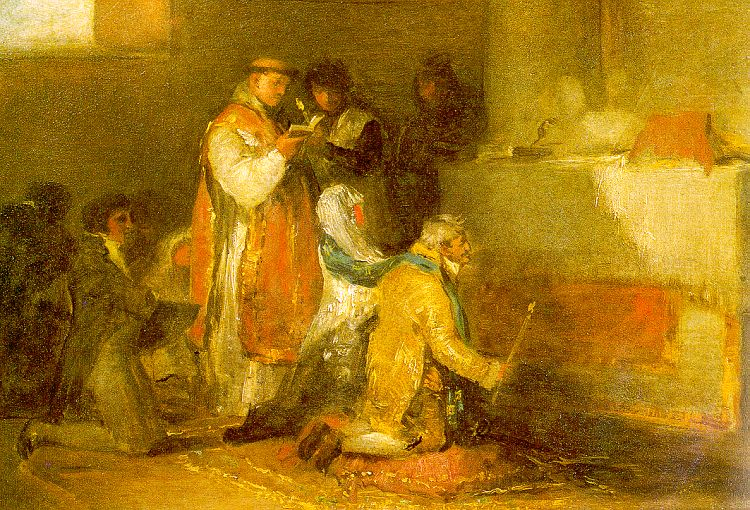What are the key elements in this picture? This image is an oil painting rendered in an impressionist style, notable for its vibrant yet loosely applied brushstrokes that capture both light and shadow effectively. The painting depicts a scene set in a room where a group of people, dressed in traditional, possibly 19th-century clothing, are engaging in daily activities. The warm color palette comprising yellows, oranges, and browns envelops the scene in a cozy, intimate atmosphere. Two figures are particularly prominent: one dressed in a striking red robe and the other in blue, bringing dynamic contrast to the composition. Specific actions such as reading and kneeling contribute to the lively, everyday nature of the scene, typical of genre painting aimed at representing daily life activities. The artist's use of color, texture, and composition not only tells a story but also evokes a feeling of nostalgia and historical curiosity. 